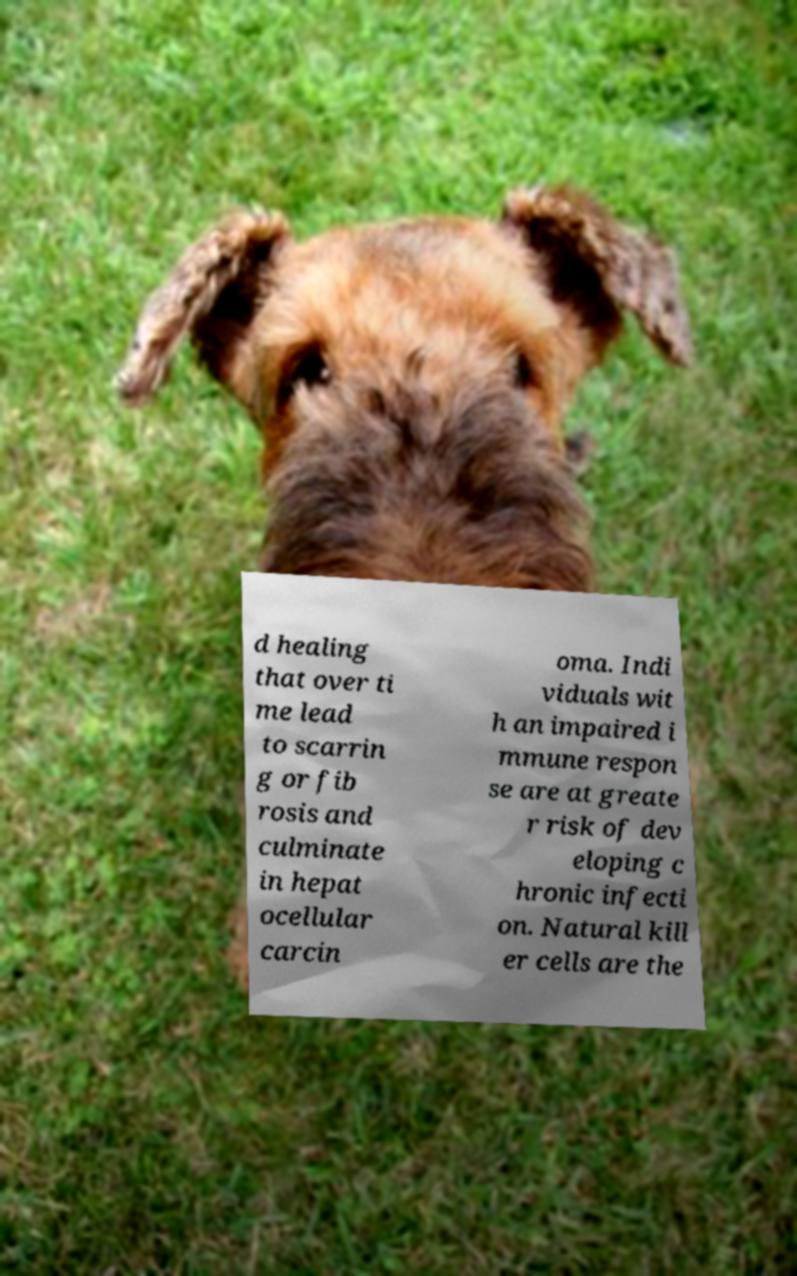Can you read and provide the text displayed in the image?This photo seems to have some interesting text. Can you extract and type it out for me? d healing that over ti me lead to scarrin g or fib rosis and culminate in hepat ocellular carcin oma. Indi viduals wit h an impaired i mmune respon se are at greate r risk of dev eloping c hronic infecti on. Natural kill er cells are the 